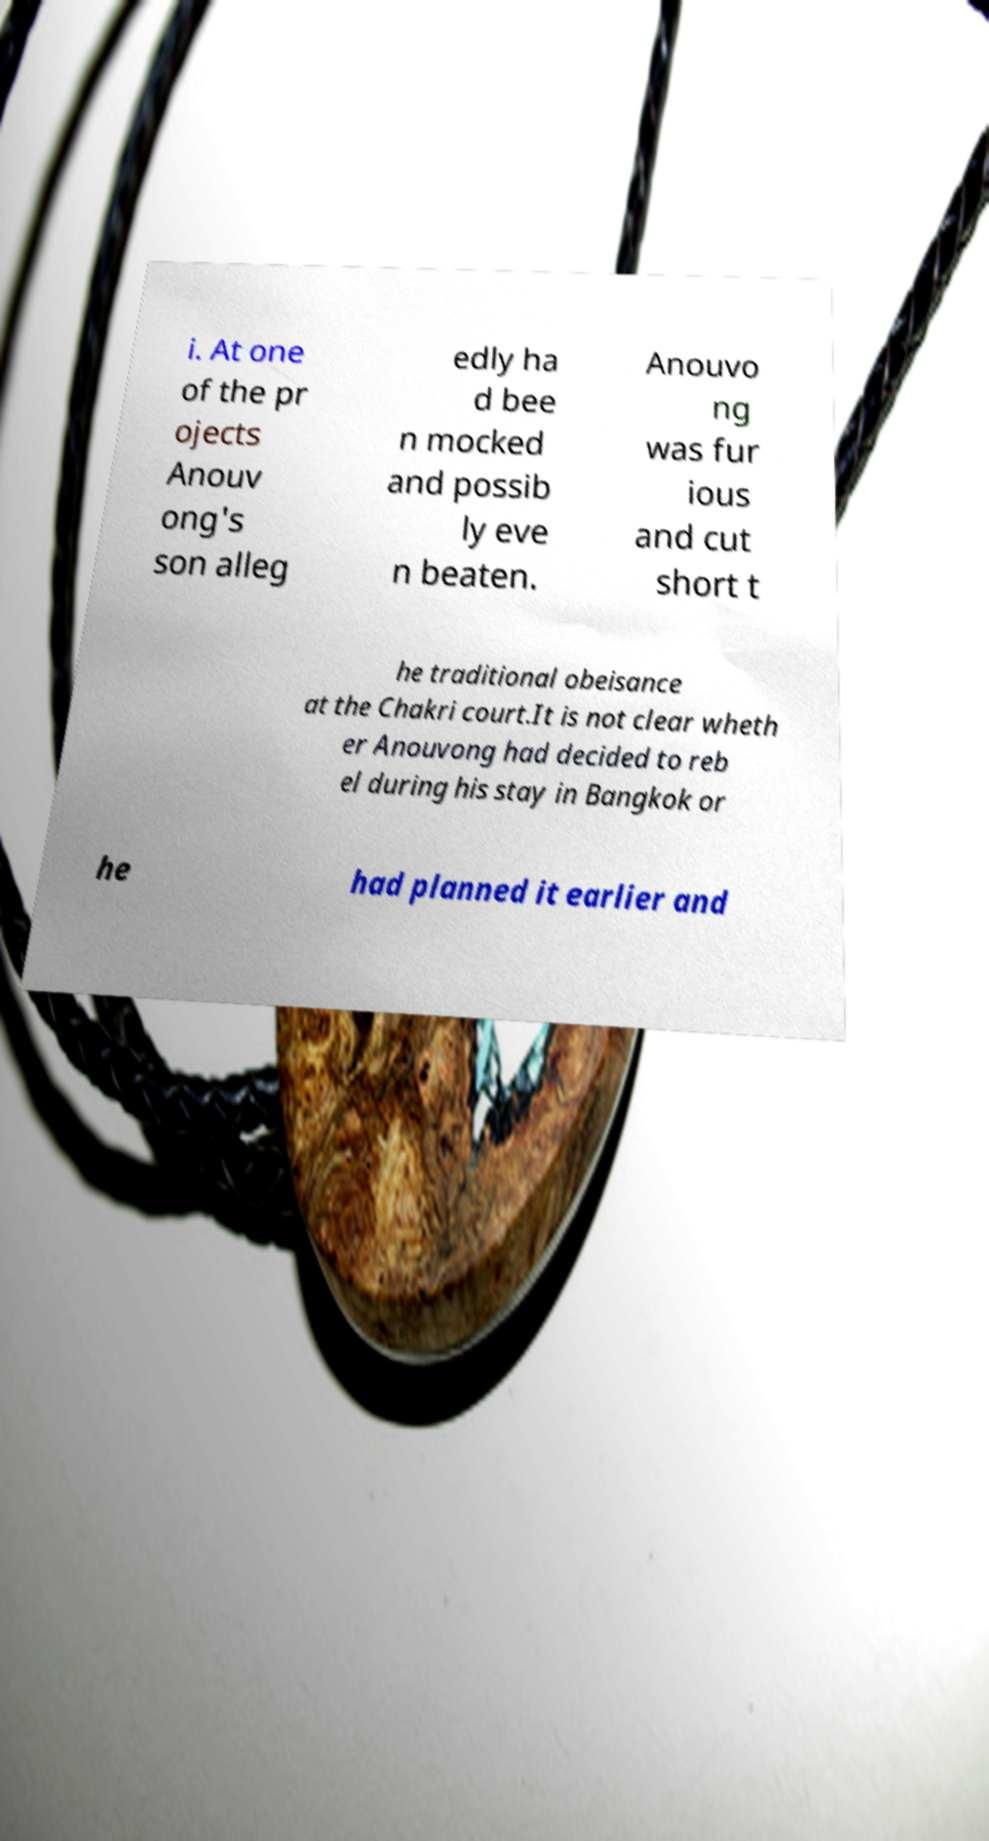Please read and relay the text visible in this image. What does it say? i. At one of the pr ojects Anouv ong's son alleg edly ha d bee n mocked and possib ly eve n beaten. Anouvo ng was fur ious and cut short t he traditional obeisance at the Chakri court.It is not clear wheth er Anouvong had decided to reb el during his stay in Bangkok or he had planned it earlier and 